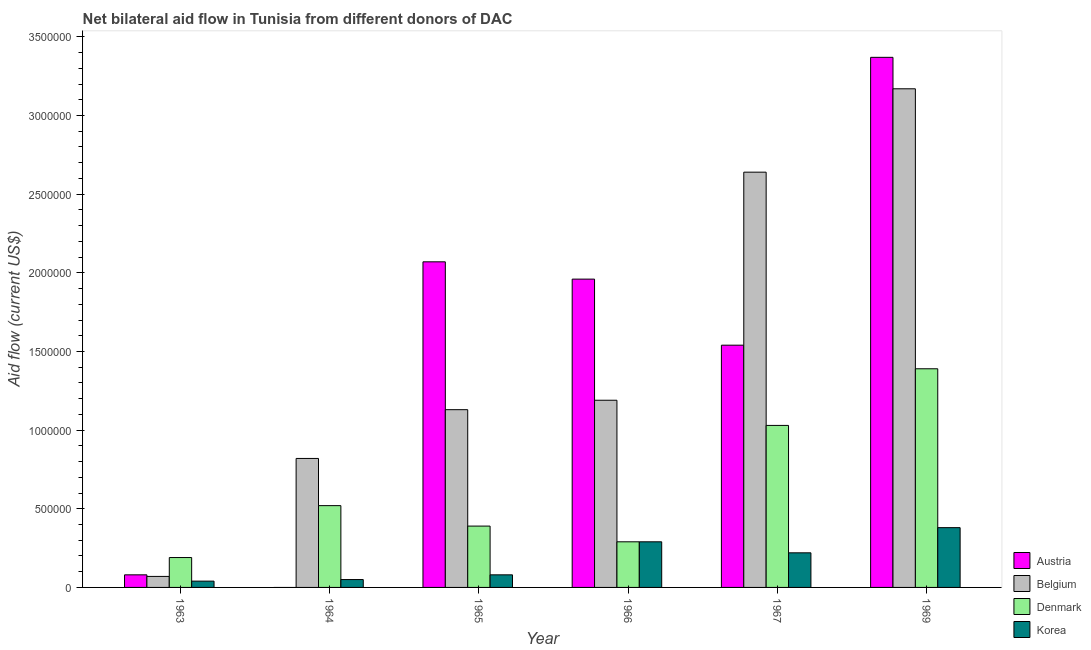Are the number of bars on each tick of the X-axis equal?
Offer a very short reply. No. How many bars are there on the 3rd tick from the left?
Your answer should be compact. 4. How many bars are there on the 1st tick from the right?
Your response must be concise. 4. What is the label of the 1st group of bars from the left?
Give a very brief answer. 1963. In how many cases, is the number of bars for a given year not equal to the number of legend labels?
Your answer should be very brief. 1. What is the amount of aid given by austria in 1965?
Offer a terse response. 2.07e+06. Across all years, what is the maximum amount of aid given by denmark?
Offer a terse response. 1.39e+06. Across all years, what is the minimum amount of aid given by belgium?
Keep it short and to the point. 7.00e+04. In which year was the amount of aid given by denmark maximum?
Your answer should be very brief. 1969. What is the total amount of aid given by belgium in the graph?
Keep it short and to the point. 9.02e+06. What is the difference between the amount of aid given by austria in 1965 and that in 1966?
Keep it short and to the point. 1.10e+05. What is the difference between the amount of aid given by denmark in 1964 and the amount of aid given by austria in 1966?
Keep it short and to the point. 2.30e+05. What is the average amount of aid given by belgium per year?
Provide a short and direct response. 1.50e+06. In how many years, is the amount of aid given by austria greater than 2300000 US$?
Your answer should be very brief. 1. What is the ratio of the amount of aid given by belgium in 1965 to that in 1967?
Ensure brevity in your answer.  0.43. Is the amount of aid given by korea in 1964 less than that in 1965?
Your answer should be compact. Yes. Is the difference between the amount of aid given by korea in 1964 and 1965 greater than the difference between the amount of aid given by denmark in 1964 and 1965?
Offer a terse response. No. What is the difference between the highest and the second highest amount of aid given by denmark?
Make the answer very short. 3.60e+05. What is the difference between the highest and the lowest amount of aid given by belgium?
Provide a short and direct response. 3.10e+06. Are all the bars in the graph horizontal?
Offer a very short reply. No. What is the difference between two consecutive major ticks on the Y-axis?
Keep it short and to the point. 5.00e+05. Does the graph contain grids?
Your answer should be compact. No. How are the legend labels stacked?
Keep it short and to the point. Vertical. What is the title of the graph?
Your answer should be very brief. Net bilateral aid flow in Tunisia from different donors of DAC. What is the Aid flow (current US$) in Austria in 1963?
Ensure brevity in your answer.  8.00e+04. What is the Aid flow (current US$) in Belgium in 1963?
Provide a succinct answer. 7.00e+04. What is the Aid flow (current US$) of Denmark in 1963?
Offer a terse response. 1.90e+05. What is the Aid flow (current US$) in Korea in 1963?
Provide a short and direct response. 4.00e+04. What is the Aid flow (current US$) in Belgium in 1964?
Offer a terse response. 8.20e+05. What is the Aid flow (current US$) in Denmark in 1964?
Ensure brevity in your answer.  5.20e+05. What is the Aid flow (current US$) in Korea in 1964?
Make the answer very short. 5.00e+04. What is the Aid flow (current US$) of Austria in 1965?
Your response must be concise. 2.07e+06. What is the Aid flow (current US$) in Belgium in 1965?
Provide a succinct answer. 1.13e+06. What is the Aid flow (current US$) of Denmark in 1965?
Offer a very short reply. 3.90e+05. What is the Aid flow (current US$) of Austria in 1966?
Ensure brevity in your answer.  1.96e+06. What is the Aid flow (current US$) in Belgium in 1966?
Offer a very short reply. 1.19e+06. What is the Aid flow (current US$) in Korea in 1966?
Your answer should be very brief. 2.90e+05. What is the Aid flow (current US$) in Austria in 1967?
Offer a very short reply. 1.54e+06. What is the Aid flow (current US$) in Belgium in 1967?
Keep it short and to the point. 2.64e+06. What is the Aid flow (current US$) in Denmark in 1967?
Keep it short and to the point. 1.03e+06. What is the Aid flow (current US$) of Austria in 1969?
Offer a very short reply. 3.37e+06. What is the Aid flow (current US$) of Belgium in 1969?
Ensure brevity in your answer.  3.17e+06. What is the Aid flow (current US$) of Denmark in 1969?
Ensure brevity in your answer.  1.39e+06. Across all years, what is the maximum Aid flow (current US$) in Austria?
Provide a succinct answer. 3.37e+06. Across all years, what is the maximum Aid flow (current US$) in Belgium?
Provide a short and direct response. 3.17e+06. Across all years, what is the maximum Aid flow (current US$) in Denmark?
Your answer should be very brief. 1.39e+06. Across all years, what is the minimum Aid flow (current US$) in Austria?
Offer a terse response. 0. Across all years, what is the minimum Aid flow (current US$) in Denmark?
Your answer should be compact. 1.90e+05. What is the total Aid flow (current US$) of Austria in the graph?
Your response must be concise. 9.02e+06. What is the total Aid flow (current US$) of Belgium in the graph?
Provide a short and direct response. 9.02e+06. What is the total Aid flow (current US$) of Denmark in the graph?
Your response must be concise. 3.81e+06. What is the total Aid flow (current US$) in Korea in the graph?
Ensure brevity in your answer.  1.06e+06. What is the difference between the Aid flow (current US$) in Belgium in 1963 and that in 1964?
Provide a succinct answer. -7.50e+05. What is the difference between the Aid flow (current US$) in Denmark in 1963 and that in 1964?
Your answer should be compact. -3.30e+05. What is the difference between the Aid flow (current US$) of Austria in 1963 and that in 1965?
Make the answer very short. -1.99e+06. What is the difference between the Aid flow (current US$) in Belgium in 1963 and that in 1965?
Offer a terse response. -1.06e+06. What is the difference between the Aid flow (current US$) of Denmark in 1963 and that in 1965?
Give a very brief answer. -2.00e+05. What is the difference between the Aid flow (current US$) in Austria in 1963 and that in 1966?
Give a very brief answer. -1.88e+06. What is the difference between the Aid flow (current US$) in Belgium in 1963 and that in 1966?
Offer a very short reply. -1.12e+06. What is the difference between the Aid flow (current US$) of Denmark in 1963 and that in 1966?
Keep it short and to the point. -1.00e+05. What is the difference between the Aid flow (current US$) in Korea in 1963 and that in 1966?
Your response must be concise. -2.50e+05. What is the difference between the Aid flow (current US$) of Austria in 1963 and that in 1967?
Ensure brevity in your answer.  -1.46e+06. What is the difference between the Aid flow (current US$) of Belgium in 1963 and that in 1967?
Offer a very short reply. -2.57e+06. What is the difference between the Aid flow (current US$) in Denmark in 1963 and that in 1967?
Offer a very short reply. -8.40e+05. What is the difference between the Aid flow (current US$) in Austria in 1963 and that in 1969?
Your answer should be very brief. -3.29e+06. What is the difference between the Aid flow (current US$) in Belgium in 1963 and that in 1969?
Your answer should be compact. -3.10e+06. What is the difference between the Aid flow (current US$) of Denmark in 1963 and that in 1969?
Your answer should be compact. -1.20e+06. What is the difference between the Aid flow (current US$) in Korea in 1963 and that in 1969?
Offer a terse response. -3.40e+05. What is the difference between the Aid flow (current US$) in Belgium in 1964 and that in 1965?
Provide a short and direct response. -3.10e+05. What is the difference between the Aid flow (current US$) in Korea in 1964 and that in 1965?
Your response must be concise. -3.00e+04. What is the difference between the Aid flow (current US$) of Belgium in 1964 and that in 1966?
Ensure brevity in your answer.  -3.70e+05. What is the difference between the Aid flow (current US$) in Korea in 1964 and that in 1966?
Ensure brevity in your answer.  -2.40e+05. What is the difference between the Aid flow (current US$) of Belgium in 1964 and that in 1967?
Your answer should be compact. -1.82e+06. What is the difference between the Aid flow (current US$) in Denmark in 1964 and that in 1967?
Offer a very short reply. -5.10e+05. What is the difference between the Aid flow (current US$) of Belgium in 1964 and that in 1969?
Provide a short and direct response. -2.35e+06. What is the difference between the Aid flow (current US$) in Denmark in 1964 and that in 1969?
Ensure brevity in your answer.  -8.70e+05. What is the difference between the Aid flow (current US$) of Korea in 1964 and that in 1969?
Ensure brevity in your answer.  -3.30e+05. What is the difference between the Aid flow (current US$) of Denmark in 1965 and that in 1966?
Provide a succinct answer. 1.00e+05. What is the difference between the Aid flow (current US$) in Korea in 1965 and that in 1966?
Keep it short and to the point. -2.10e+05. What is the difference between the Aid flow (current US$) in Austria in 1965 and that in 1967?
Your response must be concise. 5.30e+05. What is the difference between the Aid flow (current US$) of Belgium in 1965 and that in 1967?
Give a very brief answer. -1.51e+06. What is the difference between the Aid flow (current US$) in Denmark in 1965 and that in 1967?
Your response must be concise. -6.40e+05. What is the difference between the Aid flow (current US$) of Korea in 1965 and that in 1967?
Your response must be concise. -1.40e+05. What is the difference between the Aid flow (current US$) in Austria in 1965 and that in 1969?
Provide a short and direct response. -1.30e+06. What is the difference between the Aid flow (current US$) of Belgium in 1965 and that in 1969?
Keep it short and to the point. -2.04e+06. What is the difference between the Aid flow (current US$) of Denmark in 1965 and that in 1969?
Your answer should be very brief. -1.00e+06. What is the difference between the Aid flow (current US$) of Korea in 1965 and that in 1969?
Ensure brevity in your answer.  -3.00e+05. What is the difference between the Aid flow (current US$) of Belgium in 1966 and that in 1967?
Provide a succinct answer. -1.45e+06. What is the difference between the Aid flow (current US$) in Denmark in 1966 and that in 1967?
Offer a very short reply. -7.40e+05. What is the difference between the Aid flow (current US$) of Austria in 1966 and that in 1969?
Keep it short and to the point. -1.41e+06. What is the difference between the Aid flow (current US$) of Belgium in 1966 and that in 1969?
Make the answer very short. -1.98e+06. What is the difference between the Aid flow (current US$) in Denmark in 1966 and that in 1969?
Offer a very short reply. -1.10e+06. What is the difference between the Aid flow (current US$) in Austria in 1967 and that in 1969?
Give a very brief answer. -1.83e+06. What is the difference between the Aid flow (current US$) of Belgium in 1967 and that in 1969?
Keep it short and to the point. -5.30e+05. What is the difference between the Aid flow (current US$) in Denmark in 1967 and that in 1969?
Provide a succinct answer. -3.60e+05. What is the difference between the Aid flow (current US$) in Korea in 1967 and that in 1969?
Your answer should be very brief. -1.60e+05. What is the difference between the Aid flow (current US$) of Austria in 1963 and the Aid flow (current US$) of Belgium in 1964?
Provide a succinct answer. -7.40e+05. What is the difference between the Aid flow (current US$) of Austria in 1963 and the Aid flow (current US$) of Denmark in 1964?
Keep it short and to the point. -4.40e+05. What is the difference between the Aid flow (current US$) of Belgium in 1963 and the Aid flow (current US$) of Denmark in 1964?
Provide a short and direct response. -4.50e+05. What is the difference between the Aid flow (current US$) in Denmark in 1963 and the Aid flow (current US$) in Korea in 1964?
Keep it short and to the point. 1.40e+05. What is the difference between the Aid flow (current US$) in Austria in 1963 and the Aid flow (current US$) in Belgium in 1965?
Offer a very short reply. -1.05e+06. What is the difference between the Aid flow (current US$) of Austria in 1963 and the Aid flow (current US$) of Denmark in 1965?
Keep it short and to the point. -3.10e+05. What is the difference between the Aid flow (current US$) of Austria in 1963 and the Aid flow (current US$) of Korea in 1965?
Offer a very short reply. 0. What is the difference between the Aid flow (current US$) in Belgium in 1963 and the Aid flow (current US$) in Denmark in 1965?
Offer a terse response. -3.20e+05. What is the difference between the Aid flow (current US$) of Austria in 1963 and the Aid flow (current US$) of Belgium in 1966?
Give a very brief answer. -1.11e+06. What is the difference between the Aid flow (current US$) of Austria in 1963 and the Aid flow (current US$) of Korea in 1966?
Give a very brief answer. -2.10e+05. What is the difference between the Aid flow (current US$) of Belgium in 1963 and the Aid flow (current US$) of Denmark in 1966?
Provide a succinct answer. -2.20e+05. What is the difference between the Aid flow (current US$) in Austria in 1963 and the Aid flow (current US$) in Belgium in 1967?
Give a very brief answer. -2.56e+06. What is the difference between the Aid flow (current US$) in Austria in 1963 and the Aid flow (current US$) in Denmark in 1967?
Offer a terse response. -9.50e+05. What is the difference between the Aid flow (current US$) of Austria in 1963 and the Aid flow (current US$) of Korea in 1967?
Offer a terse response. -1.40e+05. What is the difference between the Aid flow (current US$) of Belgium in 1963 and the Aid flow (current US$) of Denmark in 1967?
Give a very brief answer. -9.60e+05. What is the difference between the Aid flow (current US$) of Belgium in 1963 and the Aid flow (current US$) of Korea in 1967?
Your answer should be very brief. -1.50e+05. What is the difference between the Aid flow (current US$) of Austria in 1963 and the Aid flow (current US$) of Belgium in 1969?
Offer a very short reply. -3.09e+06. What is the difference between the Aid flow (current US$) in Austria in 1963 and the Aid flow (current US$) in Denmark in 1969?
Offer a very short reply. -1.31e+06. What is the difference between the Aid flow (current US$) of Belgium in 1963 and the Aid flow (current US$) of Denmark in 1969?
Provide a short and direct response. -1.32e+06. What is the difference between the Aid flow (current US$) in Belgium in 1963 and the Aid flow (current US$) in Korea in 1969?
Your answer should be very brief. -3.10e+05. What is the difference between the Aid flow (current US$) of Belgium in 1964 and the Aid flow (current US$) of Korea in 1965?
Provide a succinct answer. 7.40e+05. What is the difference between the Aid flow (current US$) of Belgium in 1964 and the Aid flow (current US$) of Denmark in 1966?
Ensure brevity in your answer.  5.30e+05. What is the difference between the Aid flow (current US$) in Belgium in 1964 and the Aid flow (current US$) in Korea in 1966?
Your response must be concise. 5.30e+05. What is the difference between the Aid flow (current US$) in Belgium in 1964 and the Aid flow (current US$) in Denmark in 1969?
Offer a terse response. -5.70e+05. What is the difference between the Aid flow (current US$) of Denmark in 1964 and the Aid flow (current US$) of Korea in 1969?
Your response must be concise. 1.40e+05. What is the difference between the Aid flow (current US$) of Austria in 1965 and the Aid flow (current US$) of Belgium in 1966?
Your answer should be compact. 8.80e+05. What is the difference between the Aid flow (current US$) in Austria in 1965 and the Aid flow (current US$) in Denmark in 1966?
Your response must be concise. 1.78e+06. What is the difference between the Aid flow (current US$) in Austria in 1965 and the Aid flow (current US$) in Korea in 1966?
Provide a succinct answer. 1.78e+06. What is the difference between the Aid flow (current US$) in Belgium in 1965 and the Aid flow (current US$) in Denmark in 1966?
Offer a very short reply. 8.40e+05. What is the difference between the Aid flow (current US$) in Belgium in 1965 and the Aid flow (current US$) in Korea in 1966?
Keep it short and to the point. 8.40e+05. What is the difference between the Aid flow (current US$) of Austria in 1965 and the Aid flow (current US$) of Belgium in 1967?
Offer a terse response. -5.70e+05. What is the difference between the Aid flow (current US$) of Austria in 1965 and the Aid flow (current US$) of Denmark in 1967?
Keep it short and to the point. 1.04e+06. What is the difference between the Aid flow (current US$) in Austria in 1965 and the Aid flow (current US$) in Korea in 1967?
Your answer should be compact. 1.85e+06. What is the difference between the Aid flow (current US$) of Belgium in 1965 and the Aid flow (current US$) of Korea in 1967?
Make the answer very short. 9.10e+05. What is the difference between the Aid flow (current US$) of Austria in 1965 and the Aid flow (current US$) of Belgium in 1969?
Offer a terse response. -1.10e+06. What is the difference between the Aid flow (current US$) in Austria in 1965 and the Aid flow (current US$) in Denmark in 1969?
Make the answer very short. 6.80e+05. What is the difference between the Aid flow (current US$) in Austria in 1965 and the Aid flow (current US$) in Korea in 1969?
Ensure brevity in your answer.  1.69e+06. What is the difference between the Aid flow (current US$) of Belgium in 1965 and the Aid flow (current US$) of Korea in 1969?
Make the answer very short. 7.50e+05. What is the difference between the Aid flow (current US$) in Denmark in 1965 and the Aid flow (current US$) in Korea in 1969?
Ensure brevity in your answer.  10000. What is the difference between the Aid flow (current US$) in Austria in 1966 and the Aid flow (current US$) in Belgium in 1967?
Offer a terse response. -6.80e+05. What is the difference between the Aid flow (current US$) in Austria in 1966 and the Aid flow (current US$) in Denmark in 1967?
Your answer should be compact. 9.30e+05. What is the difference between the Aid flow (current US$) in Austria in 1966 and the Aid flow (current US$) in Korea in 1967?
Offer a terse response. 1.74e+06. What is the difference between the Aid flow (current US$) of Belgium in 1966 and the Aid flow (current US$) of Denmark in 1967?
Keep it short and to the point. 1.60e+05. What is the difference between the Aid flow (current US$) in Belgium in 1966 and the Aid flow (current US$) in Korea in 1967?
Provide a succinct answer. 9.70e+05. What is the difference between the Aid flow (current US$) of Denmark in 1966 and the Aid flow (current US$) of Korea in 1967?
Give a very brief answer. 7.00e+04. What is the difference between the Aid flow (current US$) in Austria in 1966 and the Aid flow (current US$) in Belgium in 1969?
Provide a short and direct response. -1.21e+06. What is the difference between the Aid flow (current US$) of Austria in 1966 and the Aid flow (current US$) of Denmark in 1969?
Keep it short and to the point. 5.70e+05. What is the difference between the Aid flow (current US$) of Austria in 1966 and the Aid flow (current US$) of Korea in 1969?
Make the answer very short. 1.58e+06. What is the difference between the Aid flow (current US$) in Belgium in 1966 and the Aid flow (current US$) in Korea in 1969?
Offer a very short reply. 8.10e+05. What is the difference between the Aid flow (current US$) of Austria in 1967 and the Aid flow (current US$) of Belgium in 1969?
Make the answer very short. -1.63e+06. What is the difference between the Aid flow (current US$) in Austria in 1967 and the Aid flow (current US$) in Korea in 1969?
Your response must be concise. 1.16e+06. What is the difference between the Aid flow (current US$) of Belgium in 1967 and the Aid flow (current US$) of Denmark in 1969?
Give a very brief answer. 1.25e+06. What is the difference between the Aid flow (current US$) in Belgium in 1967 and the Aid flow (current US$) in Korea in 1969?
Your response must be concise. 2.26e+06. What is the difference between the Aid flow (current US$) in Denmark in 1967 and the Aid flow (current US$) in Korea in 1969?
Keep it short and to the point. 6.50e+05. What is the average Aid flow (current US$) in Austria per year?
Your answer should be very brief. 1.50e+06. What is the average Aid flow (current US$) in Belgium per year?
Your answer should be compact. 1.50e+06. What is the average Aid flow (current US$) in Denmark per year?
Offer a very short reply. 6.35e+05. What is the average Aid flow (current US$) of Korea per year?
Provide a succinct answer. 1.77e+05. In the year 1963, what is the difference between the Aid flow (current US$) of Belgium and Aid flow (current US$) of Denmark?
Offer a very short reply. -1.20e+05. In the year 1963, what is the difference between the Aid flow (current US$) in Denmark and Aid flow (current US$) in Korea?
Ensure brevity in your answer.  1.50e+05. In the year 1964, what is the difference between the Aid flow (current US$) in Belgium and Aid flow (current US$) in Denmark?
Give a very brief answer. 3.00e+05. In the year 1964, what is the difference between the Aid flow (current US$) in Belgium and Aid flow (current US$) in Korea?
Your answer should be compact. 7.70e+05. In the year 1964, what is the difference between the Aid flow (current US$) in Denmark and Aid flow (current US$) in Korea?
Your response must be concise. 4.70e+05. In the year 1965, what is the difference between the Aid flow (current US$) of Austria and Aid flow (current US$) of Belgium?
Give a very brief answer. 9.40e+05. In the year 1965, what is the difference between the Aid flow (current US$) in Austria and Aid flow (current US$) in Denmark?
Ensure brevity in your answer.  1.68e+06. In the year 1965, what is the difference between the Aid flow (current US$) in Austria and Aid flow (current US$) in Korea?
Your answer should be compact. 1.99e+06. In the year 1965, what is the difference between the Aid flow (current US$) in Belgium and Aid flow (current US$) in Denmark?
Offer a very short reply. 7.40e+05. In the year 1965, what is the difference between the Aid flow (current US$) of Belgium and Aid flow (current US$) of Korea?
Make the answer very short. 1.05e+06. In the year 1965, what is the difference between the Aid flow (current US$) of Denmark and Aid flow (current US$) of Korea?
Offer a terse response. 3.10e+05. In the year 1966, what is the difference between the Aid flow (current US$) of Austria and Aid flow (current US$) of Belgium?
Make the answer very short. 7.70e+05. In the year 1966, what is the difference between the Aid flow (current US$) in Austria and Aid flow (current US$) in Denmark?
Provide a short and direct response. 1.67e+06. In the year 1966, what is the difference between the Aid flow (current US$) of Austria and Aid flow (current US$) of Korea?
Keep it short and to the point. 1.67e+06. In the year 1966, what is the difference between the Aid flow (current US$) of Belgium and Aid flow (current US$) of Denmark?
Give a very brief answer. 9.00e+05. In the year 1966, what is the difference between the Aid flow (current US$) in Belgium and Aid flow (current US$) in Korea?
Provide a short and direct response. 9.00e+05. In the year 1966, what is the difference between the Aid flow (current US$) of Denmark and Aid flow (current US$) of Korea?
Your response must be concise. 0. In the year 1967, what is the difference between the Aid flow (current US$) of Austria and Aid flow (current US$) of Belgium?
Your response must be concise. -1.10e+06. In the year 1967, what is the difference between the Aid flow (current US$) in Austria and Aid flow (current US$) in Denmark?
Provide a short and direct response. 5.10e+05. In the year 1967, what is the difference between the Aid flow (current US$) of Austria and Aid flow (current US$) of Korea?
Offer a very short reply. 1.32e+06. In the year 1967, what is the difference between the Aid flow (current US$) of Belgium and Aid flow (current US$) of Denmark?
Your answer should be very brief. 1.61e+06. In the year 1967, what is the difference between the Aid flow (current US$) in Belgium and Aid flow (current US$) in Korea?
Keep it short and to the point. 2.42e+06. In the year 1967, what is the difference between the Aid flow (current US$) of Denmark and Aid flow (current US$) of Korea?
Provide a short and direct response. 8.10e+05. In the year 1969, what is the difference between the Aid flow (current US$) in Austria and Aid flow (current US$) in Denmark?
Offer a very short reply. 1.98e+06. In the year 1969, what is the difference between the Aid flow (current US$) in Austria and Aid flow (current US$) in Korea?
Your response must be concise. 2.99e+06. In the year 1969, what is the difference between the Aid flow (current US$) in Belgium and Aid flow (current US$) in Denmark?
Your answer should be compact. 1.78e+06. In the year 1969, what is the difference between the Aid flow (current US$) of Belgium and Aid flow (current US$) of Korea?
Your answer should be very brief. 2.79e+06. In the year 1969, what is the difference between the Aid flow (current US$) in Denmark and Aid flow (current US$) in Korea?
Make the answer very short. 1.01e+06. What is the ratio of the Aid flow (current US$) of Belgium in 1963 to that in 1964?
Provide a short and direct response. 0.09. What is the ratio of the Aid flow (current US$) of Denmark in 1963 to that in 1964?
Provide a short and direct response. 0.37. What is the ratio of the Aid flow (current US$) of Korea in 1963 to that in 1964?
Provide a short and direct response. 0.8. What is the ratio of the Aid flow (current US$) in Austria in 1963 to that in 1965?
Your answer should be very brief. 0.04. What is the ratio of the Aid flow (current US$) in Belgium in 1963 to that in 1965?
Ensure brevity in your answer.  0.06. What is the ratio of the Aid flow (current US$) of Denmark in 1963 to that in 1965?
Provide a short and direct response. 0.49. What is the ratio of the Aid flow (current US$) of Korea in 1963 to that in 1965?
Give a very brief answer. 0.5. What is the ratio of the Aid flow (current US$) of Austria in 1963 to that in 1966?
Provide a short and direct response. 0.04. What is the ratio of the Aid flow (current US$) of Belgium in 1963 to that in 1966?
Your answer should be very brief. 0.06. What is the ratio of the Aid flow (current US$) in Denmark in 1963 to that in 1966?
Make the answer very short. 0.66. What is the ratio of the Aid flow (current US$) of Korea in 1963 to that in 1966?
Make the answer very short. 0.14. What is the ratio of the Aid flow (current US$) of Austria in 1963 to that in 1967?
Provide a short and direct response. 0.05. What is the ratio of the Aid flow (current US$) of Belgium in 1963 to that in 1967?
Offer a terse response. 0.03. What is the ratio of the Aid flow (current US$) in Denmark in 1963 to that in 1967?
Provide a succinct answer. 0.18. What is the ratio of the Aid flow (current US$) in Korea in 1963 to that in 1967?
Provide a succinct answer. 0.18. What is the ratio of the Aid flow (current US$) in Austria in 1963 to that in 1969?
Your answer should be compact. 0.02. What is the ratio of the Aid flow (current US$) in Belgium in 1963 to that in 1969?
Keep it short and to the point. 0.02. What is the ratio of the Aid flow (current US$) in Denmark in 1963 to that in 1969?
Keep it short and to the point. 0.14. What is the ratio of the Aid flow (current US$) in Korea in 1963 to that in 1969?
Provide a succinct answer. 0.11. What is the ratio of the Aid flow (current US$) in Belgium in 1964 to that in 1965?
Make the answer very short. 0.73. What is the ratio of the Aid flow (current US$) in Denmark in 1964 to that in 1965?
Provide a short and direct response. 1.33. What is the ratio of the Aid flow (current US$) in Belgium in 1964 to that in 1966?
Make the answer very short. 0.69. What is the ratio of the Aid flow (current US$) of Denmark in 1964 to that in 1966?
Offer a terse response. 1.79. What is the ratio of the Aid flow (current US$) in Korea in 1964 to that in 1966?
Offer a very short reply. 0.17. What is the ratio of the Aid flow (current US$) in Belgium in 1964 to that in 1967?
Make the answer very short. 0.31. What is the ratio of the Aid flow (current US$) of Denmark in 1964 to that in 1967?
Offer a terse response. 0.5. What is the ratio of the Aid flow (current US$) of Korea in 1964 to that in 1967?
Give a very brief answer. 0.23. What is the ratio of the Aid flow (current US$) in Belgium in 1964 to that in 1969?
Your answer should be very brief. 0.26. What is the ratio of the Aid flow (current US$) of Denmark in 1964 to that in 1969?
Your answer should be very brief. 0.37. What is the ratio of the Aid flow (current US$) of Korea in 1964 to that in 1969?
Make the answer very short. 0.13. What is the ratio of the Aid flow (current US$) in Austria in 1965 to that in 1966?
Your response must be concise. 1.06. What is the ratio of the Aid flow (current US$) of Belgium in 1965 to that in 1966?
Provide a succinct answer. 0.95. What is the ratio of the Aid flow (current US$) of Denmark in 1965 to that in 1966?
Keep it short and to the point. 1.34. What is the ratio of the Aid flow (current US$) of Korea in 1965 to that in 1966?
Your response must be concise. 0.28. What is the ratio of the Aid flow (current US$) in Austria in 1965 to that in 1967?
Your answer should be very brief. 1.34. What is the ratio of the Aid flow (current US$) of Belgium in 1965 to that in 1967?
Offer a very short reply. 0.43. What is the ratio of the Aid flow (current US$) in Denmark in 1965 to that in 1967?
Make the answer very short. 0.38. What is the ratio of the Aid flow (current US$) of Korea in 1965 to that in 1967?
Ensure brevity in your answer.  0.36. What is the ratio of the Aid flow (current US$) in Austria in 1965 to that in 1969?
Give a very brief answer. 0.61. What is the ratio of the Aid flow (current US$) of Belgium in 1965 to that in 1969?
Keep it short and to the point. 0.36. What is the ratio of the Aid flow (current US$) of Denmark in 1965 to that in 1969?
Your response must be concise. 0.28. What is the ratio of the Aid flow (current US$) in Korea in 1965 to that in 1969?
Provide a short and direct response. 0.21. What is the ratio of the Aid flow (current US$) of Austria in 1966 to that in 1967?
Keep it short and to the point. 1.27. What is the ratio of the Aid flow (current US$) of Belgium in 1966 to that in 1967?
Your answer should be very brief. 0.45. What is the ratio of the Aid flow (current US$) of Denmark in 1966 to that in 1967?
Provide a short and direct response. 0.28. What is the ratio of the Aid flow (current US$) of Korea in 1966 to that in 1967?
Ensure brevity in your answer.  1.32. What is the ratio of the Aid flow (current US$) in Austria in 1966 to that in 1969?
Your response must be concise. 0.58. What is the ratio of the Aid flow (current US$) of Belgium in 1966 to that in 1969?
Provide a succinct answer. 0.38. What is the ratio of the Aid flow (current US$) in Denmark in 1966 to that in 1969?
Your response must be concise. 0.21. What is the ratio of the Aid flow (current US$) of Korea in 1966 to that in 1969?
Offer a terse response. 0.76. What is the ratio of the Aid flow (current US$) of Austria in 1967 to that in 1969?
Provide a short and direct response. 0.46. What is the ratio of the Aid flow (current US$) in Belgium in 1967 to that in 1969?
Your answer should be compact. 0.83. What is the ratio of the Aid flow (current US$) of Denmark in 1967 to that in 1969?
Your answer should be very brief. 0.74. What is the ratio of the Aid flow (current US$) in Korea in 1967 to that in 1969?
Give a very brief answer. 0.58. What is the difference between the highest and the second highest Aid flow (current US$) in Austria?
Make the answer very short. 1.30e+06. What is the difference between the highest and the second highest Aid flow (current US$) in Belgium?
Make the answer very short. 5.30e+05. What is the difference between the highest and the second highest Aid flow (current US$) of Korea?
Your answer should be very brief. 9.00e+04. What is the difference between the highest and the lowest Aid flow (current US$) in Austria?
Make the answer very short. 3.37e+06. What is the difference between the highest and the lowest Aid flow (current US$) of Belgium?
Offer a very short reply. 3.10e+06. What is the difference between the highest and the lowest Aid flow (current US$) in Denmark?
Provide a short and direct response. 1.20e+06. 